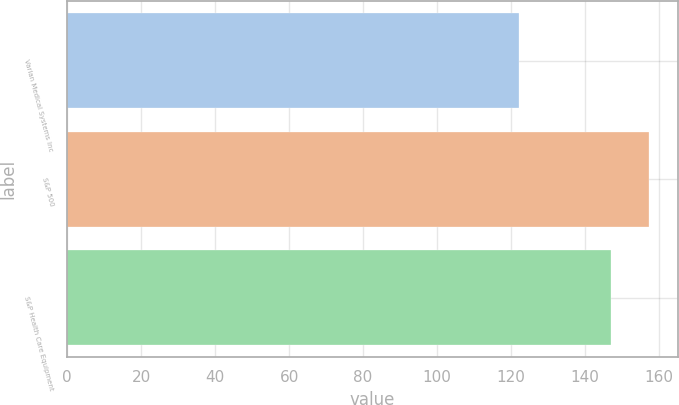Convert chart to OTSL. <chart><loc_0><loc_0><loc_500><loc_500><bar_chart><fcel>Varian Medical Systems Inc<fcel>S&P 500<fcel>S&P Health Care Equipment<nl><fcel>122.25<fcel>157.17<fcel>146.9<nl></chart> 